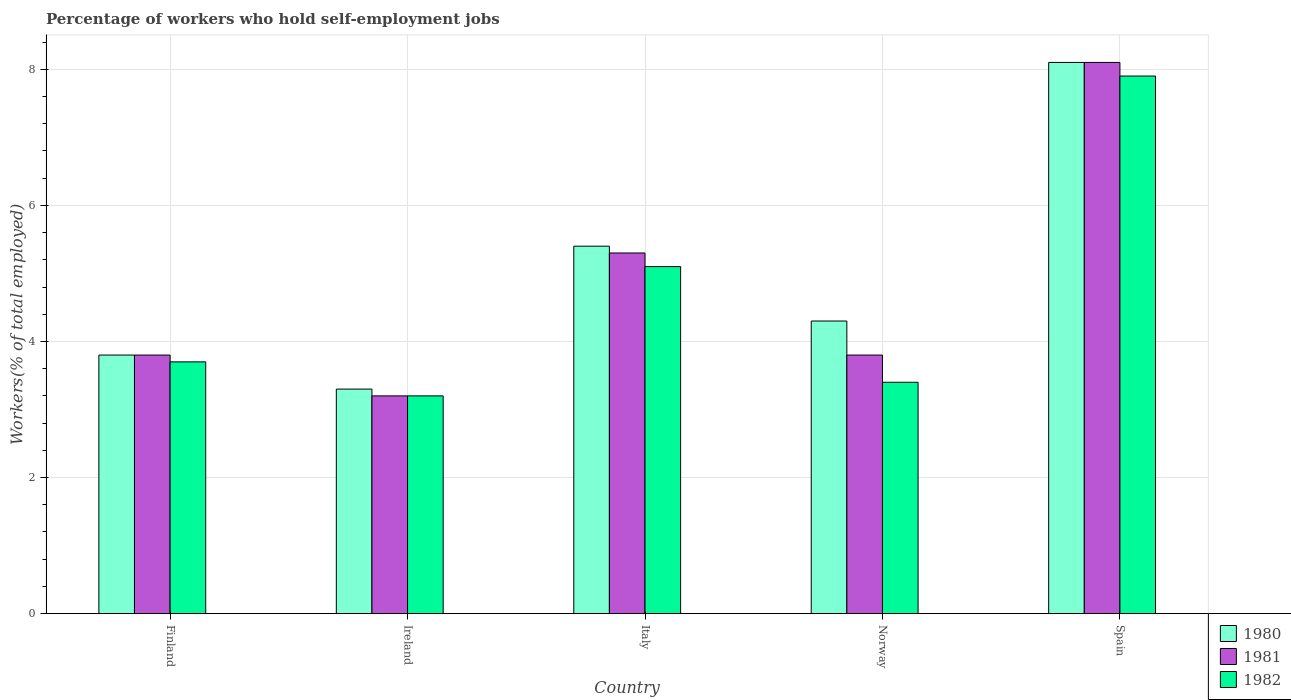How many different coloured bars are there?
Keep it short and to the point. 3. Are the number of bars per tick equal to the number of legend labels?
Offer a very short reply. Yes. Are the number of bars on each tick of the X-axis equal?
Offer a very short reply. Yes. How many bars are there on the 5th tick from the right?
Keep it short and to the point. 3. In how many cases, is the number of bars for a given country not equal to the number of legend labels?
Provide a succinct answer. 0. What is the percentage of self-employed workers in 1980 in Ireland?
Provide a short and direct response. 3.3. Across all countries, what is the maximum percentage of self-employed workers in 1982?
Ensure brevity in your answer.  7.9. Across all countries, what is the minimum percentage of self-employed workers in 1980?
Your answer should be very brief. 3.3. In which country was the percentage of self-employed workers in 1981 minimum?
Your answer should be compact. Ireland. What is the total percentage of self-employed workers in 1981 in the graph?
Provide a short and direct response. 24.2. What is the difference between the percentage of self-employed workers in 1982 in Italy and that in Spain?
Your answer should be compact. -2.8. What is the difference between the percentage of self-employed workers in 1980 in Ireland and the percentage of self-employed workers in 1981 in Italy?
Give a very brief answer. -2. What is the average percentage of self-employed workers in 1982 per country?
Ensure brevity in your answer.  4.66. What is the difference between the percentage of self-employed workers of/in 1982 and percentage of self-employed workers of/in 1980 in Italy?
Provide a succinct answer. -0.3. In how many countries, is the percentage of self-employed workers in 1982 greater than 0.8 %?
Ensure brevity in your answer.  5. What is the ratio of the percentage of self-employed workers in 1980 in Finland to that in Ireland?
Ensure brevity in your answer.  1.15. Is the percentage of self-employed workers in 1980 in Norway less than that in Spain?
Provide a short and direct response. Yes. Is the difference between the percentage of self-employed workers in 1982 in Finland and Spain greater than the difference between the percentage of self-employed workers in 1980 in Finland and Spain?
Offer a terse response. Yes. What is the difference between the highest and the second highest percentage of self-employed workers in 1981?
Your answer should be very brief. 4.3. What is the difference between the highest and the lowest percentage of self-employed workers in 1980?
Your response must be concise. 4.8. In how many countries, is the percentage of self-employed workers in 1982 greater than the average percentage of self-employed workers in 1982 taken over all countries?
Offer a very short reply. 2. Is the sum of the percentage of self-employed workers in 1981 in Ireland and Spain greater than the maximum percentage of self-employed workers in 1980 across all countries?
Ensure brevity in your answer.  Yes. What does the 1st bar from the right in Norway represents?
Ensure brevity in your answer.  1982. How many bars are there?
Provide a short and direct response. 15. Are all the bars in the graph horizontal?
Offer a terse response. No. How many countries are there in the graph?
Make the answer very short. 5. Are the values on the major ticks of Y-axis written in scientific E-notation?
Offer a terse response. No. Does the graph contain any zero values?
Provide a short and direct response. No. Where does the legend appear in the graph?
Your answer should be compact. Bottom right. How are the legend labels stacked?
Your answer should be compact. Vertical. What is the title of the graph?
Your answer should be compact. Percentage of workers who hold self-employment jobs. What is the label or title of the X-axis?
Your response must be concise. Country. What is the label or title of the Y-axis?
Keep it short and to the point. Workers(% of total employed). What is the Workers(% of total employed) of 1980 in Finland?
Keep it short and to the point. 3.8. What is the Workers(% of total employed) of 1981 in Finland?
Provide a succinct answer. 3.8. What is the Workers(% of total employed) of 1982 in Finland?
Offer a very short reply. 3.7. What is the Workers(% of total employed) in 1980 in Ireland?
Provide a short and direct response. 3.3. What is the Workers(% of total employed) in 1981 in Ireland?
Provide a succinct answer. 3.2. What is the Workers(% of total employed) of 1982 in Ireland?
Give a very brief answer. 3.2. What is the Workers(% of total employed) of 1980 in Italy?
Provide a succinct answer. 5.4. What is the Workers(% of total employed) of 1981 in Italy?
Offer a very short reply. 5.3. What is the Workers(% of total employed) in 1982 in Italy?
Keep it short and to the point. 5.1. What is the Workers(% of total employed) of 1980 in Norway?
Your response must be concise. 4.3. What is the Workers(% of total employed) of 1981 in Norway?
Ensure brevity in your answer.  3.8. What is the Workers(% of total employed) in 1982 in Norway?
Your response must be concise. 3.4. What is the Workers(% of total employed) in 1980 in Spain?
Your answer should be very brief. 8.1. What is the Workers(% of total employed) in 1981 in Spain?
Ensure brevity in your answer.  8.1. What is the Workers(% of total employed) in 1982 in Spain?
Provide a short and direct response. 7.9. Across all countries, what is the maximum Workers(% of total employed) in 1980?
Your response must be concise. 8.1. Across all countries, what is the maximum Workers(% of total employed) in 1981?
Offer a very short reply. 8.1. Across all countries, what is the maximum Workers(% of total employed) in 1982?
Ensure brevity in your answer.  7.9. Across all countries, what is the minimum Workers(% of total employed) of 1980?
Your answer should be compact. 3.3. Across all countries, what is the minimum Workers(% of total employed) in 1981?
Provide a short and direct response. 3.2. Across all countries, what is the minimum Workers(% of total employed) of 1982?
Give a very brief answer. 3.2. What is the total Workers(% of total employed) in 1980 in the graph?
Offer a very short reply. 24.9. What is the total Workers(% of total employed) of 1981 in the graph?
Your response must be concise. 24.2. What is the total Workers(% of total employed) in 1982 in the graph?
Give a very brief answer. 23.3. What is the difference between the Workers(% of total employed) of 1981 in Finland and that in Ireland?
Provide a short and direct response. 0.6. What is the difference between the Workers(% of total employed) in 1982 in Finland and that in Ireland?
Provide a succinct answer. 0.5. What is the difference between the Workers(% of total employed) of 1981 in Finland and that in Norway?
Provide a succinct answer. 0. What is the difference between the Workers(% of total employed) of 1982 in Finland and that in Norway?
Make the answer very short. 0.3. What is the difference between the Workers(% of total employed) in 1980 in Finland and that in Spain?
Give a very brief answer. -4.3. What is the difference between the Workers(% of total employed) in 1981 in Finland and that in Spain?
Keep it short and to the point. -4.3. What is the difference between the Workers(% of total employed) in 1981 in Ireland and that in Italy?
Provide a succinct answer. -2.1. What is the difference between the Workers(% of total employed) of 1981 in Ireland and that in Norway?
Your answer should be compact. -0.6. What is the difference between the Workers(% of total employed) in 1982 in Ireland and that in Norway?
Offer a very short reply. -0.2. What is the difference between the Workers(% of total employed) in 1981 in Ireland and that in Spain?
Your answer should be compact. -4.9. What is the difference between the Workers(% of total employed) of 1982 in Italy and that in Spain?
Offer a very short reply. -2.8. What is the difference between the Workers(% of total employed) of 1980 in Norway and that in Spain?
Your answer should be very brief. -3.8. What is the difference between the Workers(% of total employed) in 1980 in Finland and the Workers(% of total employed) in 1981 in Ireland?
Ensure brevity in your answer.  0.6. What is the difference between the Workers(% of total employed) in 1980 in Finland and the Workers(% of total employed) in 1982 in Ireland?
Your answer should be compact. 0.6. What is the difference between the Workers(% of total employed) of 1981 in Finland and the Workers(% of total employed) of 1982 in Ireland?
Your response must be concise. 0.6. What is the difference between the Workers(% of total employed) of 1980 in Finland and the Workers(% of total employed) of 1981 in Italy?
Keep it short and to the point. -1.5. What is the difference between the Workers(% of total employed) in 1980 in Finland and the Workers(% of total employed) in 1982 in Norway?
Your answer should be very brief. 0.4. What is the difference between the Workers(% of total employed) in 1981 in Finland and the Workers(% of total employed) in 1982 in Norway?
Your answer should be very brief. 0.4. What is the difference between the Workers(% of total employed) of 1980 in Finland and the Workers(% of total employed) of 1982 in Spain?
Make the answer very short. -4.1. What is the difference between the Workers(% of total employed) in 1980 in Ireland and the Workers(% of total employed) in 1981 in Norway?
Make the answer very short. -0.5. What is the difference between the Workers(% of total employed) in 1980 in Italy and the Workers(% of total employed) in 1982 in Norway?
Your answer should be compact. 2. What is the difference between the Workers(% of total employed) in 1981 in Italy and the Workers(% of total employed) in 1982 in Norway?
Make the answer very short. 1.9. What is the difference between the Workers(% of total employed) in 1980 in Italy and the Workers(% of total employed) in 1981 in Spain?
Your answer should be very brief. -2.7. What is the difference between the Workers(% of total employed) of 1980 in Norway and the Workers(% of total employed) of 1981 in Spain?
Your answer should be compact. -3.8. What is the difference between the Workers(% of total employed) of 1980 in Norway and the Workers(% of total employed) of 1982 in Spain?
Your answer should be compact. -3.6. What is the difference between the Workers(% of total employed) of 1981 in Norway and the Workers(% of total employed) of 1982 in Spain?
Keep it short and to the point. -4.1. What is the average Workers(% of total employed) of 1980 per country?
Provide a short and direct response. 4.98. What is the average Workers(% of total employed) of 1981 per country?
Keep it short and to the point. 4.84. What is the average Workers(% of total employed) in 1982 per country?
Provide a short and direct response. 4.66. What is the difference between the Workers(% of total employed) of 1980 and Workers(% of total employed) of 1982 in Finland?
Provide a short and direct response. 0.1. What is the difference between the Workers(% of total employed) of 1980 and Workers(% of total employed) of 1981 in Ireland?
Ensure brevity in your answer.  0.1. What is the difference between the Workers(% of total employed) of 1981 and Workers(% of total employed) of 1982 in Ireland?
Give a very brief answer. 0. What is the difference between the Workers(% of total employed) in 1980 and Workers(% of total employed) in 1981 in Italy?
Your response must be concise. 0.1. What is the difference between the Workers(% of total employed) in 1981 and Workers(% of total employed) in 1982 in Italy?
Provide a succinct answer. 0.2. What is the difference between the Workers(% of total employed) in 1980 and Workers(% of total employed) in 1982 in Norway?
Keep it short and to the point. 0.9. What is the difference between the Workers(% of total employed) of 1981 and Workers(% of total employed) of 1982 in Norway?
Make the answer very short. 0.4. What is the difference between the Workers(% of total employed) of 1981 and Workers(% of total employed) of 1982 in Spain?
Your response must be concise. 0.2. What is the ratio of the Workers(% of total employed) in 1980 in Finland to that in Ireland?
Ensure brevity in your answer.  1.15. What is the ratio of the Workers(% of total employed) in 1981 in Finland to that in Ireland?
Offer a very short reply. 1.19. What is the ratio of the Workers(% of total employed) in 1982 in Finland to that in Ireland?
Provide a succinct answer. 1.16. What is the ratio of the Workers(% of total employed) in 1980 in Finland to that in Italy?
Ensure brevity in your answer.  0.7. What is the ratio of the Workers(% of total employed) in 1981 in Finland to that in Italy?
Provide a short and direct response. 0.72. What is the ratio of the Workers(% of total employed) of 1982 in Finland to that in Italy?
Your answer should be very brief. 0.73. What is the ratio of the Workers(% of total employed) in 1980 in Finland to that in Norway?
Ensure brevity in your answer.  0.88. What is the ratio of the Workers(% of total employed) of 1982 in Finland to that in Norway?
Offer a terse response. 1.09. What is the ratio of the Workers(% of total employed) of 1980 in Finland to that in Spain?
Provide a succinct answer. 0.47. What is the ratio of the Workers(% of total employed) in 1981 in Finland to that in Spain?
Offer a very short reply. 0.47. What is the ratio of the Workers(% of total employed) of 1982 in Finland to that in Spain?
Your answer should be compact. 0.47. What is the ratio of the Workers(% of total employed) in 1980 in Ireland to that in Italy?
Make the answer very short. 0.61. What is the ratio of the Workers(% of total employed) in 1981 in Ireland to that in Italy?
Ensure brevity in your answer.  0.6. What is the ratio of the Workers(% of total employed) of 1982 in Ireland to that in Italy?
Offer a very short reply. 0.63. What is the ratio of the Workers(% of total employed) in 1980 in Ireland to that in Norway?
Keep it short and to the point. 0.77. What is the ratio of the Workers(% of total employed) in 1981 in Ireland to that in Norway?
Give a very brief answer. 0.84. What is the ratio of the Workers(% of total employed) of 1980 in Ireland to that in Spain?
Keep it short and to the point. 0.41. What is the ratio of the Workers(% of total employed) in 1981 in Ireland to that in Spain?
Offer a terse response. 0.4. What is the ratio of the Workers(% of total employed) of 1982 in Ireland to that in Spain?
Ensure brevity in your answer.  0.41. What is the ratio of the Workers(% of total employed) in 1980 in Italy to that in Norway?
Your response must be concise. 1.26. What is the ratio of the Workers(% of total employed) in 1981 in Italy to that in Norway?
Provide a short and direct response. 1.39. What is the ratio of the Workers(% of total employed) of 1982 in Italy to that in Norway?
Provide a succinct answer. 1.5. What is the ratio of the Workers(% of total employed) in 1980 in Italy to that in Spain?
Offer a terse response. 0.67. What is the ratio of the Workers(% of total employed) in 1981 in Italy to that in Spain?
Your response must be concise. 0.65. What is the ratio of the Workers(% of total employed) in 1982 in Italy to that in Spain?
Your response must be concise. 0.65. What is the ratio of the Workers(% of total employed) of 1980 in Norway to that in Spain?
Offer a very short reply. 0.53. What is the ratio of the Workers(% of total employed) in 1981 in Norway to that in Spain?
Ensure brevity in your answer.  0.47. What is the ratio of the Workers(% of total employed) in 1982 in Norway to that in Spain?
Provide a succinct answer. 0.43. What is the difference between the highest and the second highest Workers(% of total employed) of 1980?
Offer a very short reply. 2.7. What is the difference between the highest and the second highest Workers(% of total employed) in 1981?
Provide a succinct answer. 2.8. What is the difference between the highest and the second highest Workers(% of total employed) of 1982?
Offer a terse response. 2.8. What is the difference between the highest and the lowest Workers(% of total employed) in 1982?
Your answer should be very brief. 4.7. 